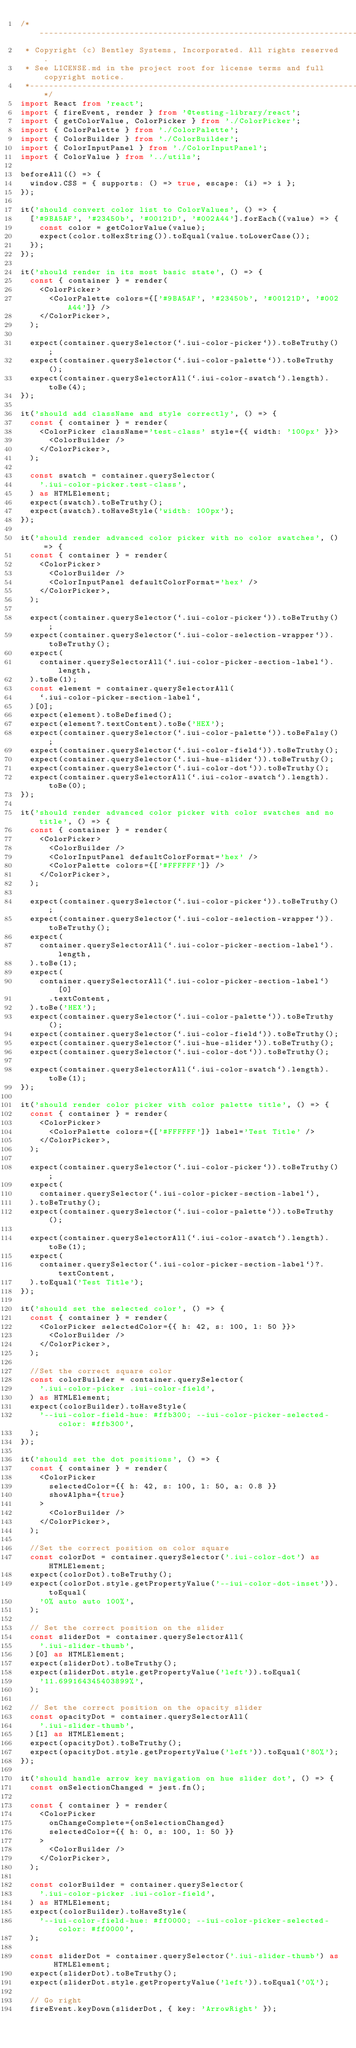<code> <loc_0><loc_0><loc_500><loc_500><_TypeScript_>/*---------------------------------------------------------------------------------------------
 * Copyright (c) Bentley Systems, Incorporated. All rights reserved.
 * See LICENSE.md in the project root for license terms and full copyright notice.
 *--------------------------------------------------------------------------------------------*/
import React from 'react';
import { fireEvent, render } from '@testing-library/react';
import { getColorValue, ColorPicker } from './ColorPicker';
import { ColorPalette } from './ColorPalette';
import { ColorBuilder } from './ColorBuilder';
import { ColorInputPanel } from './ColorInputPanel';
import { ColorValue } from '../utils';

beforeAll(() => {
  window.CSS = { supports: () => true, escape: (i) => i };
});

it('should convert color list to ColorValues', () => {
  ['#9BA5AF', '#23450b', '#00121D', '#002A44'].forEach((value) => {
    const color = getColorValue(value);
    expect(color.toHexString()).toEqual(value.toLowerCase());
  });
});

it('should render in its most basic state', () => {
  const { container } = render(
    <ColorPicker>
      <ColorPalette colors={['#9BA5AF', '#23450b', '#00121D', '#002A44']} />
    </ColorPicker>,
  );

  expect(container.querySelector(`.iui-color-picker`)).toBeTruthy();
  expect(container.querySelector(`.iui-color-palette`)).toBeTruthy();
  expect(container.querySelectorAll(`.iui-color-swatch`).length).toBe(4);
});

it('should add className and style correctly', () => {
  const { container } = render(
    <ColorPicker className='test-class' style={{ width: '100px' }}>
      <ColorBuilder />
    </ColorPicker>,
  );

  const swatch = container.querySelector(
    '.iui-color-picker.test-class',
  ) as HTMLElement;
  expect(swatch).toBeTruthy();
  expect(swatch).toHaveStyle('width: 100px');
});

it('should render advanced color picker with no color swatches', () => {
  const { container } = render(
    <ColorPicker>
      <ColorBuilder />
      <ColorInputPanel defaultColorFormat='hex' />
    </ColorPicker>,
  );

  expect(container.querySelector(`.iui-color-picker`)).toBeTruthy();
  expect(container.querySelector(`.iui-color-selection-wrapper`)).toBeTruthy();
  expect(
    container.querySelectorAll(`.iui-color-picker-section-label`).length,
  ).toBe(1);
  const element = container.querySelectorAll(
    `.iui-color-picker-section-label`,
  )[0];
  expect(element).toBeDefined();
  expect(element?.textContent).toBe('HEX');
  expect(container.querySelector(`.iui-color-palette`)).toBeFalsy();
  expect(container.querySelector(`.iui-color-field`)).toBeTruthy();
  expect(container.querySelector(`.iui-hue-slider`)).toBeTruthy();
  expect(container.querySelector(`.iui-color-dot`)).toBeTruthy();
  expect(container.querySelectorAll(`.iui-color-swatch`).length).toBe(0);
});

it('should render advanced color picker with color swatches and no title', () => {
  const { container } = render(
    <ColorPicker>
      <ColorBuilder />
      <ColorInputPanel defaultColorFormat='hex' />
      <ColorPalette colors={['#FFFFFF']} />
    </ColorPicker>,
  );

  expect(container.querySelector(`.iui-color-picker`)).toBeTruthy();
  expect(container.querySelector(`.iui-color-selection-wrapper`)).toBeTruthy();
  expect(
    container.querySelectorAll(`.iui-color-picker-section-label`).length,
  ).toBe(1);
  expect(
    container.querySelectorAll(`.iui-color-picker-section-label`)[0]
      .textContent,
  ).toBe('HEX');
  expect(container.querySelector(`.iui-color-palette`)).toBeTruthy();
  expect(container.querySelector(`.iui-color-field`)).toBeTruthy();
  expect(container.querySelector(`.iui-hue-slider`)).toBeTruthy();
  expect(container.querySelector(`.iui-color-dot`)).toBeTruthy();

  expect(container.querySelectorAll(`.iui-color-swatch`).length).toBe(1);
});

it('should render color picker with color palette title', () => {
  const { container } = render(
    <ColorPicker>
      <ColorPalette colors={['#FFFFFF']} label='Test Title' />
    </ColorPicker>,
  );

  expect(container.querySelector(`.iui-color-picker`)).toBeTruthy();
  expect(
    container.querySelector(`.iui-color-picker-section-label`),
  ).toBeTruthy();
  expect(container.querySelector(`.iui-color-palette`)).toBeTruthy();

  expect(container.querySelectorAll(`.iui-color-swatch`).length).toBe(1);
  expect(
    container.querySelector(`.iui-color-picker-section-label`)?.textContent,
  ).toEqual('Test Title');
});

it('should set the selected color', () => {
  const { container } = render(
    <ColorPicker selectedColor={{ h: 42, s: 100, l: 50 }}>
      <ColorBuilder />
    </ColorPicker>,
  );

  //Set the correct square color
  const colorBuilder = container.querySelector(
    '.iui-color-picker .iui-color-field',
  ) as HTMLElement;
  expect(colorBuilder).toHaveStyle(
    '--iui-color-field-hue: #ffb300; --iui-color-picker-selected-color: #ffb300',
  );
});

it('should set the dot positions', () => {
  const { container } = render(
    <ColorPicker
      selectedColor={{ h: 42, s: 100, l: 50, a: 0.8 }}
      showAlpha={true}
    >
      <ColorBuilder />
    </ColorPicker>,
  );

  //Set the correct position on color square
  const colorDot = container.querySelector('.iui-color-dot') as HTMLElement;
  expect(colorDot).toBeTruthy();
  expect(colorDot.style.getPropertyValue('--iui-color-dot-inset')).toEqual(
    '0% auto auto 100%',
  );

  // Set the correct position on the slider
  const sliderDot = container.querySelectorAll(
    '.iui-slider-thumb',
  )[0] as HTMLElement;
  expect(sliderDot).toBeTruthy();
  expect(sliderDot.style.getPropertyValue('left')).toEqual(
    '11.699164345403899%',
  );

  // Set the correct position on the opacity slider
  const opacityDot = container.querySelectorAll(
    '.iui-slider-thumb',
  )[1] as HTMLElement;
  expect(opacityDot).toBeTruthy();
  expect(opacityDot.style.getPropertyValue('left')).toEqual('80%');
});

it('should handle arrow key navigation on hue slider dot', () => {
  const onSelectionChanged = jest.fn();

  const { container } = render(
    <ColorPicker
      onChangeComplete={onSelectionChanged}
      selectedColor={{ h: 0, s: 100, l: 50 }}
    >
      <ColorBuilder />
    </ColorPicker>,
  );

  const colorBuilder = container.querySelector(
    '.iui-color-picker .iui-color-field',
  ) as HTMLElement;
  expect(colorBuilder).toHaveStyle(
    '--iui-color-field-hue: #ff0000; --iui-color-picker-selected-color: #ff0000',
  );

  const sliderDot = container.querySelector('.iui-slider-thumb') as HTMLElement;
  expect(sliderDot).toBeTruthy();
  expect(sliderDot.style.getPropertyValue('left')).toEqual('0%');

  // Go right
  fireEvent.keyDown(sliderDot, { key: 'ArrowRight' });</code> 